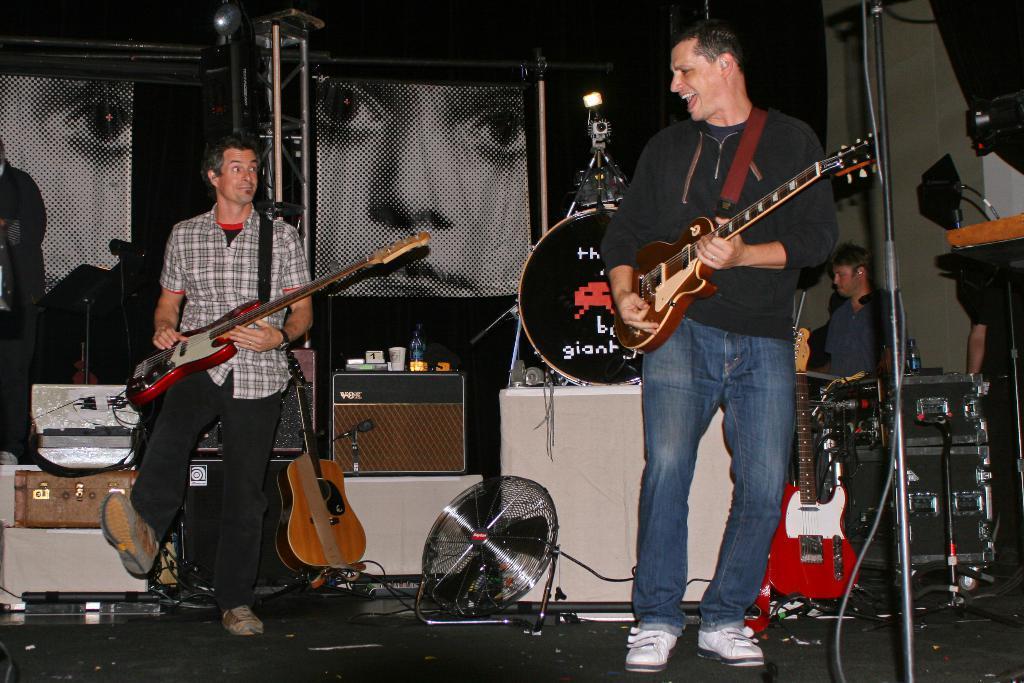Describe this image in one or two sentences. Here we can see two persons are standing on the floor, and playing the guitar, and here is the stand, and here are some objects. 